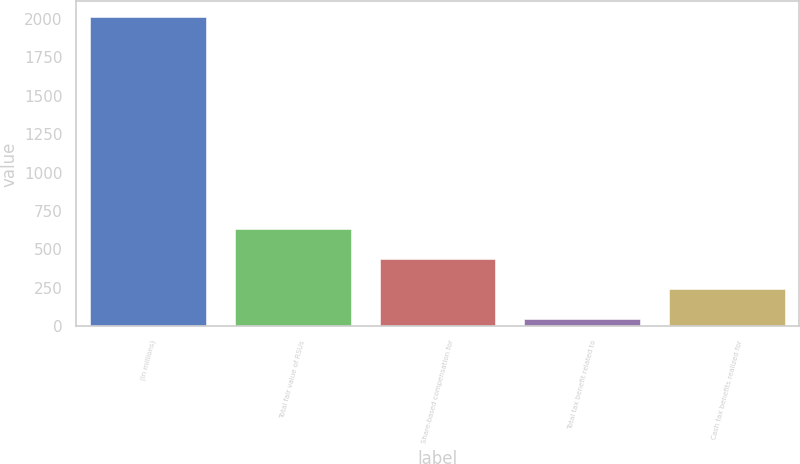<chart> <loc_0><loc_0><loc_500><loc_500><bar_chart><fcel>(In millions)<fcel>Total fair value of RSUs<fcel>Share-based compensation for<fcel>Total tax benefit related to<fcel>Cash tax benefits realized for<nl><fcel>2013<fcel>636.1<fcel>439.4<fcel>46<fcel>242.7<nl></chart> 